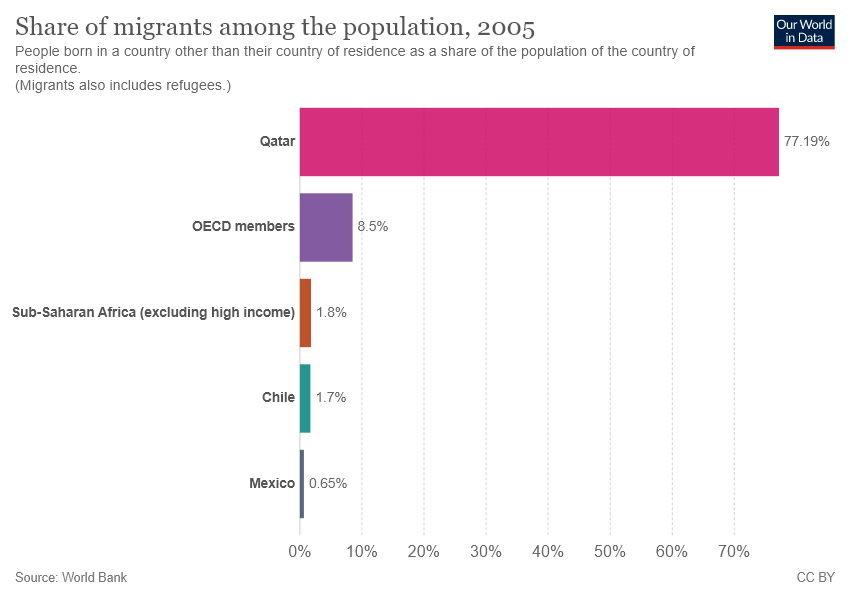Indicate a few pertinent items in this graphic. The total value of the three smallest bars is less than the value of the second largest bar. The value of the smallest bar is 0.65. 